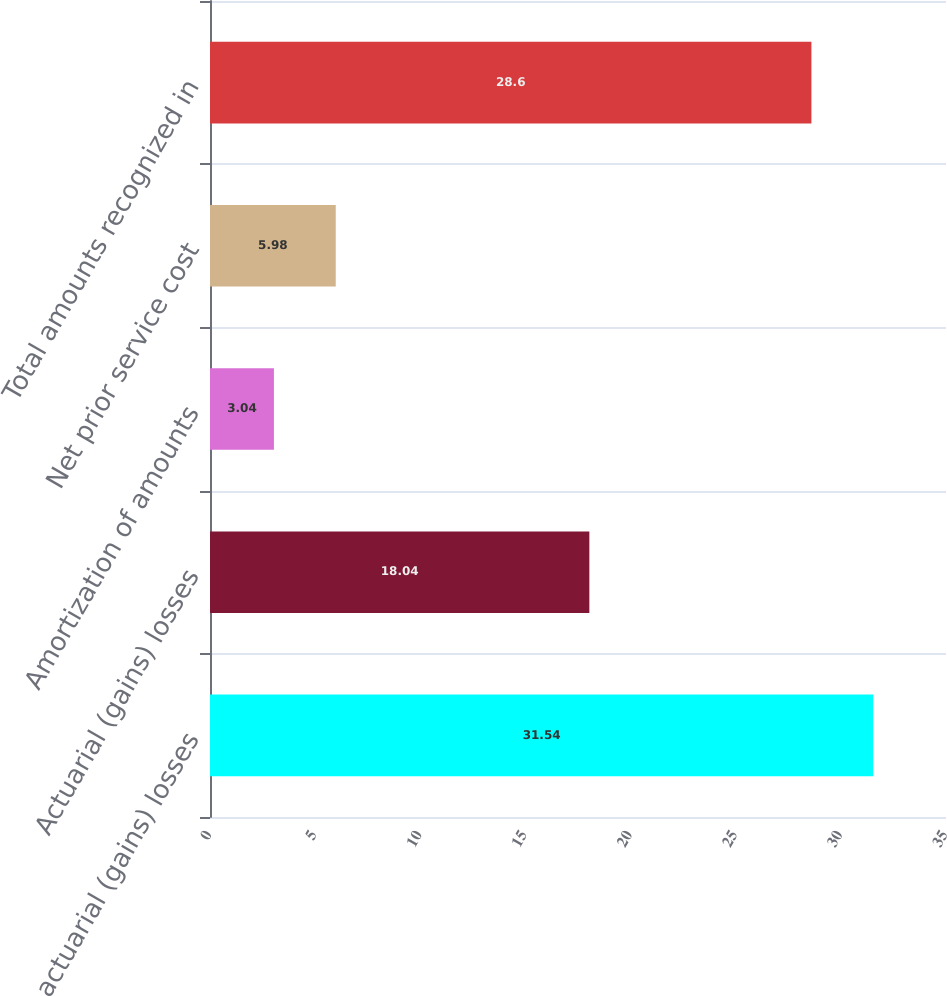<chart> <loc_0><loc_0><loc_500><loc_500><bar_chart><fcel>Net actuarial (gains) losses<fcel>Actuarial (gains) losses<fcel>Amortization of amounts<fcel>Net prior service cost<fcel>Total amounts recognized in<nl><fcel>31.54<fcel>18.04<fcel>3.04<fcel>5.98<fcel>28.6<nl></chart> 